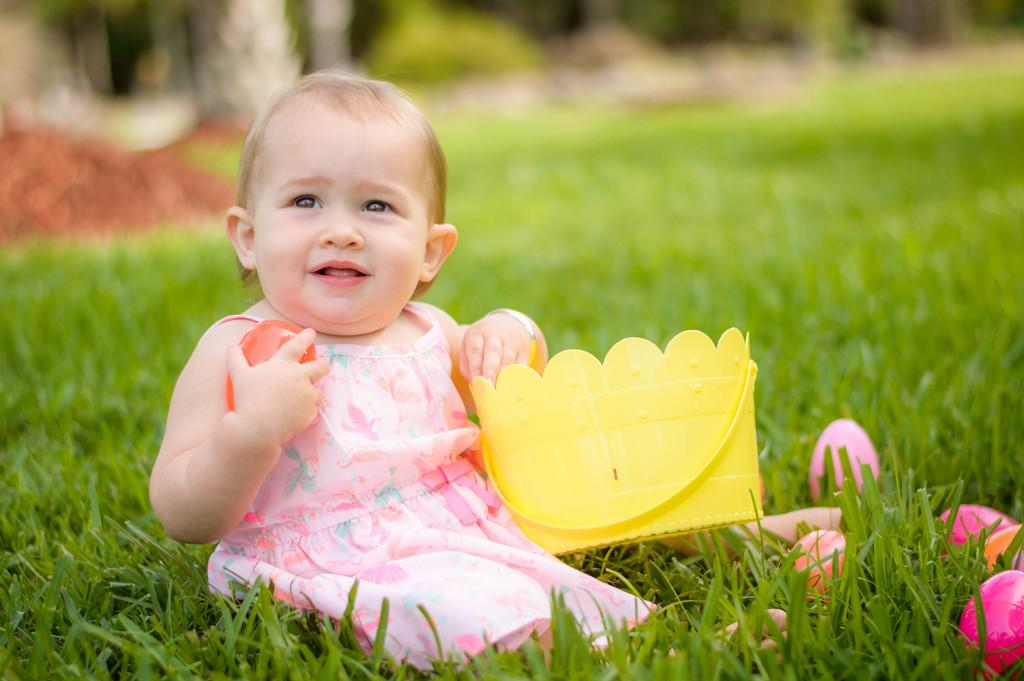What is the baby doing in the image? The baby is sitting on the grass in the image. What is the baby holding in the image? The baby is holding objects in the image. What can be seen on the right side of the image? There are toys on the right side of the image. How would you describe the background of the image? The background has a blurred view. Is there a river flowing through the background of the image? No, there is no river visible in the image. Can you see any farm animals in the image? No, there are no farm animals present in the image. 